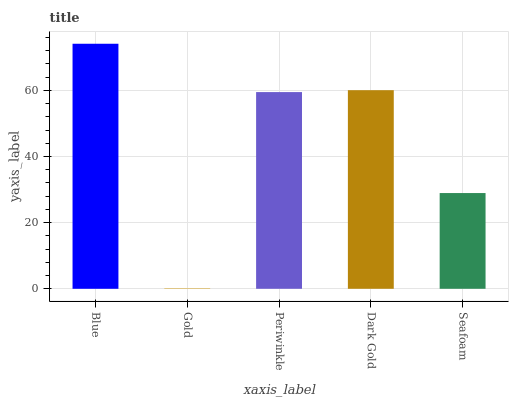Is Periwinkle the minimum?
Answer yes or no. No. Is Periwinkle the maximum?
Answer yes or no. No. Is Periwinkle greater than Gold?
Answer yes or no. Yes. Is Gold less than Periwinkle?
Answer yes or no. Yes. Is Gold greater than Periwinkle?
Answer yes or no. No. Is Periwinkle less than Gold?
Answer yes or no. No. Is Periwinkle the high median?
Answer yes or no. Yes. Is Periwinkle the low median?
Answer yes or no. Yes. Is Seafoam the high median?
Answer yes or no. No. Is Dark Gold the low median?
Answer yes or no. No. 